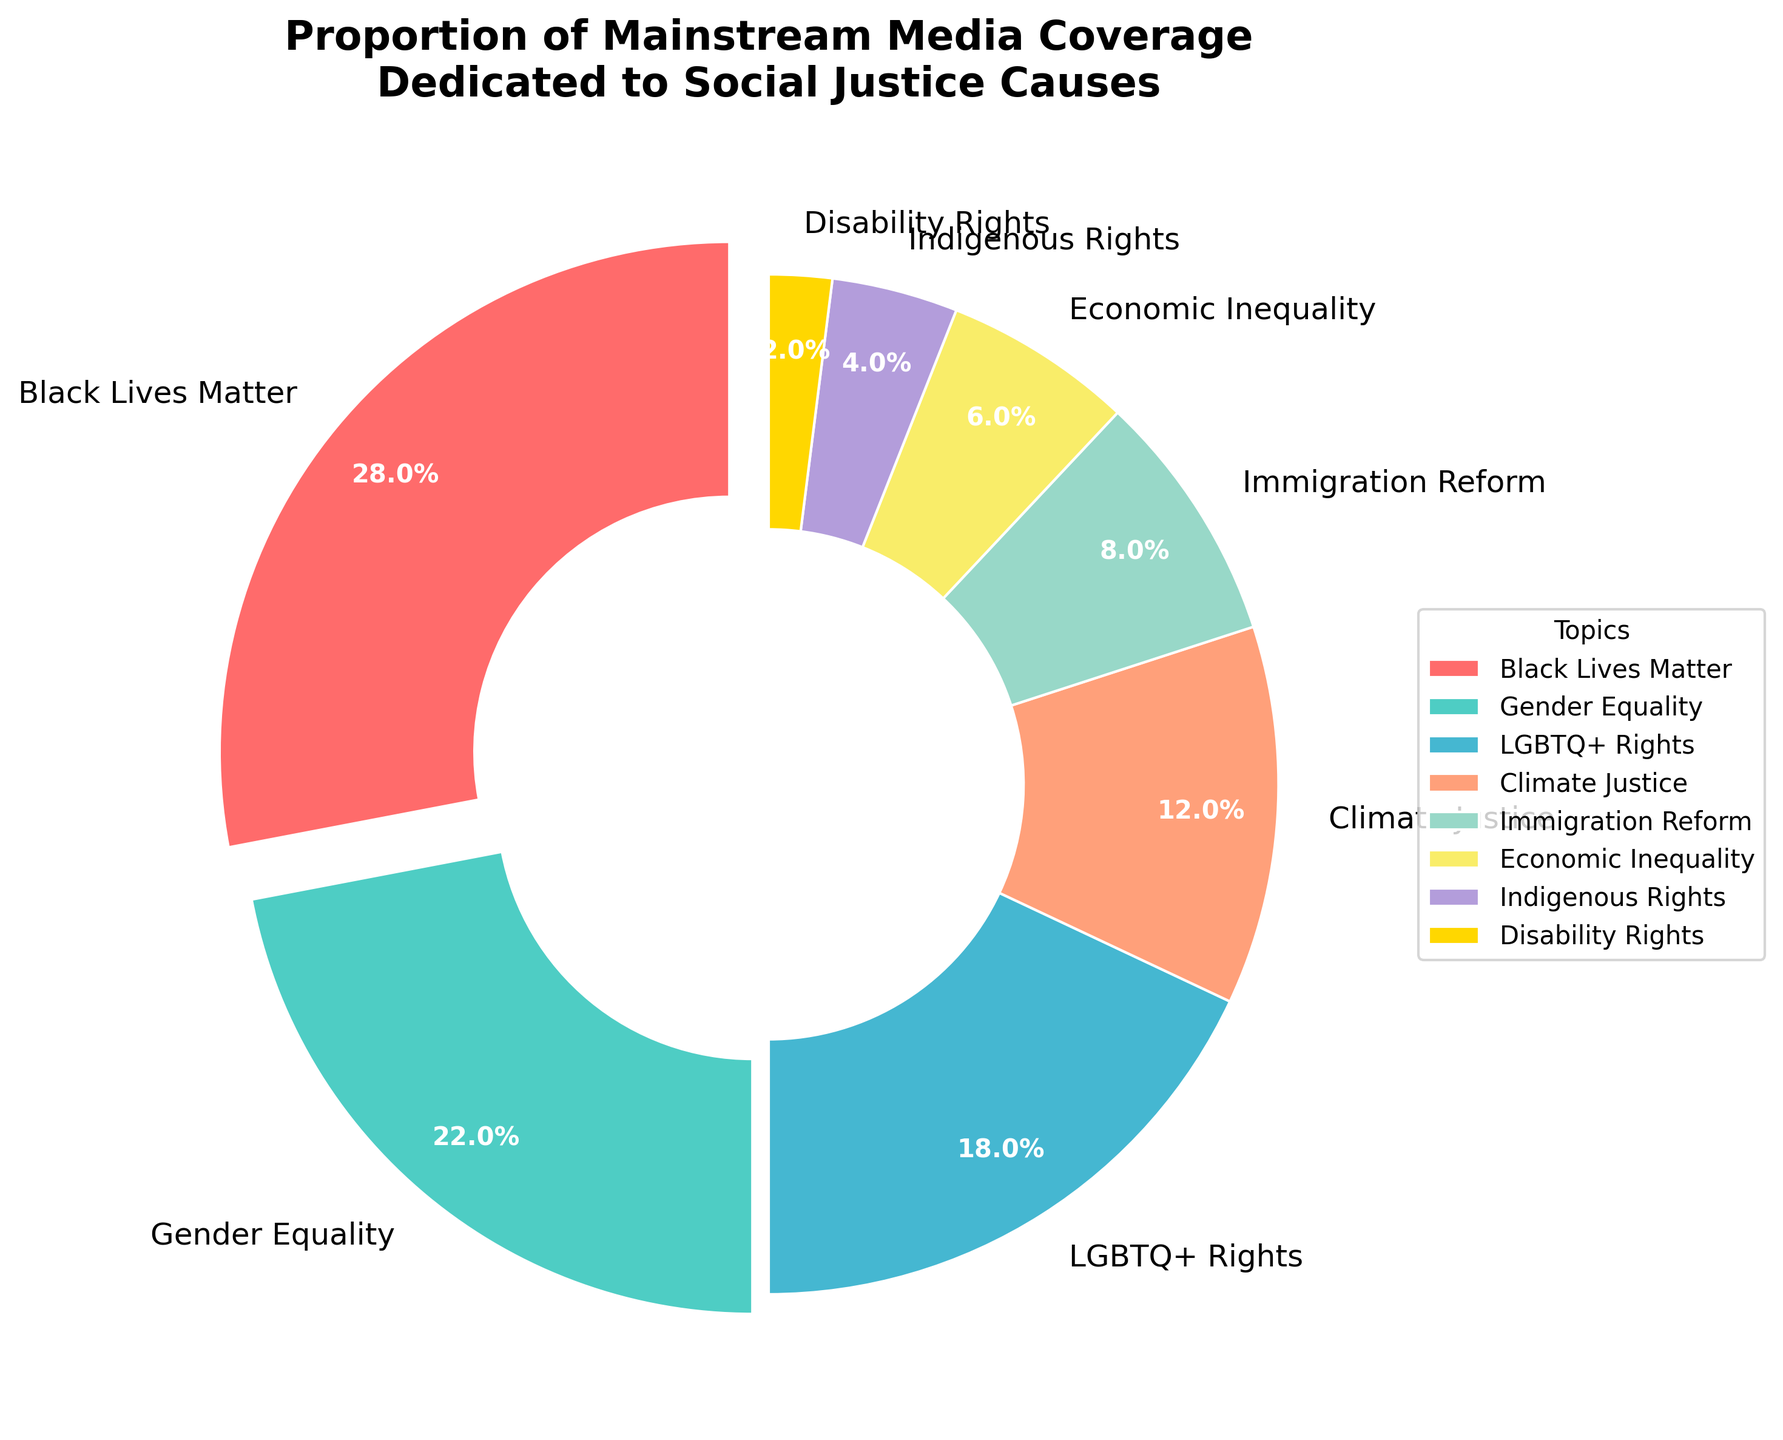What is the combined percentage of media coverage for Black Lives Matter and Gender Equality? To get the combined percentage of media coverage for Black Lives Matter and Gender Equality, add their respective percentages: 28% (Black Lives Matter) + 22% (Gender Equality) = 50%
Answer: 50% Which social justice cause receives the least media coverage? To identify the social justice cause with the least media coverage, look for the smallest percentage in the chart. Disability Rights has the smallest percentage at 2%.
Answer: Disability Rights How much more media coverage does Black Lives Matter receive compared to Economic Inequality? Calculate the difference in media coverage between Black Lives Matter and Economic Inequality: 28% (Black Lives Matter) - 6% (Economic Inequality) = 22%
Answer: 22% What is the sum of the percentages for Climate Justice, Indigenous Rights, and Disability Rights? Add the percentages for Climate Justice, Indigenous Rights, and Disability Rights: 12% (Climate Justice) + 4% (Indigenous Rights) + 2% (Disability Rights) = 18%
Answer: 18% Which cause receives more media coverage: LGBTQ+ Rights or Immigration Reform? Compare the percentages of media coverage for LGBTQ+ Rights and Immigration Reform: 18% (LGBTQ+ Rights) > 8% (Immigration Reform)
Answer: LGBTQ+ Rights How many causes receive less than 10% of the media coverage each? Identify the causes with percentages less than 10%: Immigration Reform, Economic Inequality, Indigenous Rights, and Disability Rights. There are 4 such causes.
Answer: 4 What is the difference in media coverage between Gender Equality and Climate Justice? Calculate the difference in media coverage between Gender Equality and Climate Justice: 22% (Gender Equality) - 12% (Climate Justice) = 10%
Answer: 10% What proportion of the chart is dedicated to Economic Inequality and Indigenous Rights combined? Add the percentages of Economic Inequality and Indigenous Rights to find the combined proportion: 6% (Economic Inequality) + 4% (Indigenous Rights) = 10%
Answer: 10% Which section is represented by the orange-colored wedge? The orange-colored wedge represents Climate Justice, based on the chart's color coding.
Answer: Climate Justice 